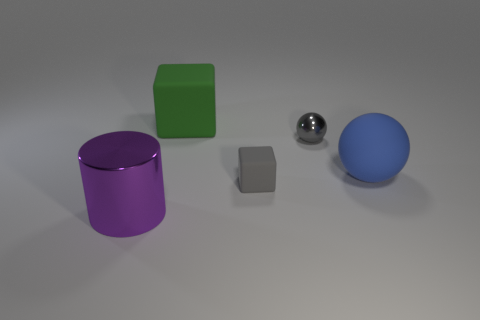Add 1 shiny things. How many objects exist? 6 Subtract all cylinders. How many objects are left? 4 Add 2 big things. How many big things are left? 5 Add 4 large metallic cylinders. How many large metallic cylinders exist? 5 Subtract 0 green cylinders. How many objects are left? 5 Subtract all gray shiny objects. Subtract all big purple objects. How many objects are left? 3 